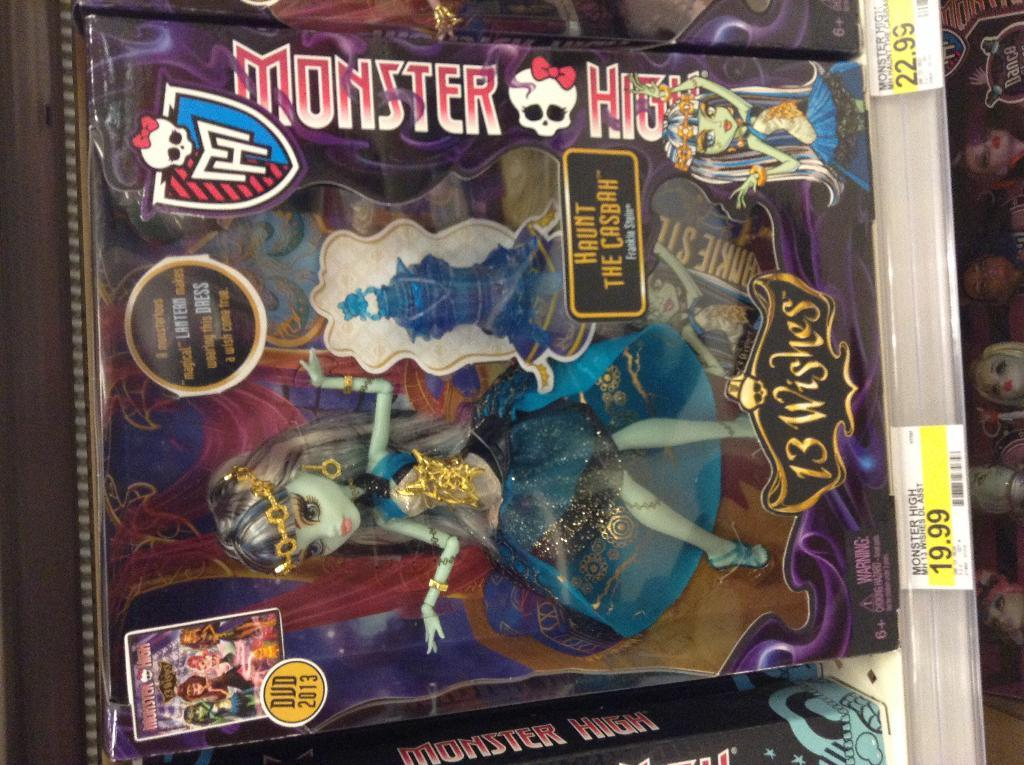What is inside the box that is visible in the image? There is a barbie doll packed in a box in the image. What can be seen on the surface of the box? There are labels and stickers on the box. What else can be seen on the right side of the image? There are dolls on the right side of the image. What type of mint is growing near the dolls on the right side of the image? There is no mint present in the image; it only features a barbie doll packed in a box and dolls on the right side. 